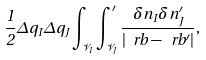<formula> <loc_0><loc_0><loc_500><loc_500>\frac { 1 } { 2 } \Delta q _ { I } \Delta q _ { J } \int _ { \mathcal { V } _ { I } } \int ^ { \prime } _ { \mathcal { V } _ { J } } \frac { \delta n _ { I } \delta n _ { J } ^ { \prime } } { | \ r b - \ r b ^ { \prime } | } ,</formula> 